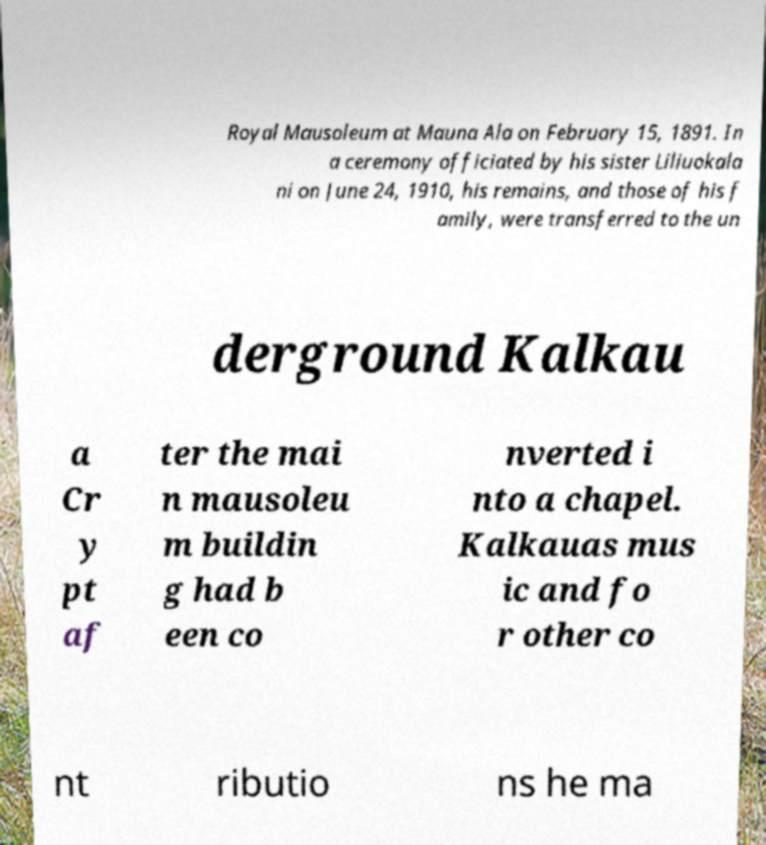Can you accurately transcribe the text from the provided image for me? Royal Mausoleum at Mauna Ala on February 15, 1891. In a ceremony officiated by his sister Liliuokala ni on June 24, 1910, his remains, and those of his f amily, were transferred to the un derground Kalkau a Cr y pt af ter the mai n mausoleu m buildin g had b een co nverted i nto a chapel. Kalkauas mus ic and fo r other co nt ributio ns he ma 